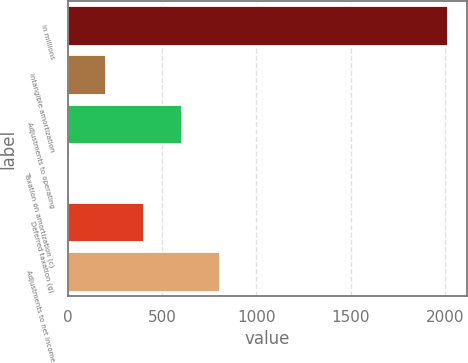<chart> <loc_0><loc_0><loc_500><loc_500><bar_chart><fcel>in millions<fcel>Intangible amortization<fcel>Adjustments to operating<fcel>Taxation on amortization (c)<fcel>Deferred taxation (g)<fcel>Adjustments to net income<nl><fcel>2016<fcel>202.77<fcel>605.71<fcel>1.3<fcel>404.24<fcel>807.18<nl></chart> 